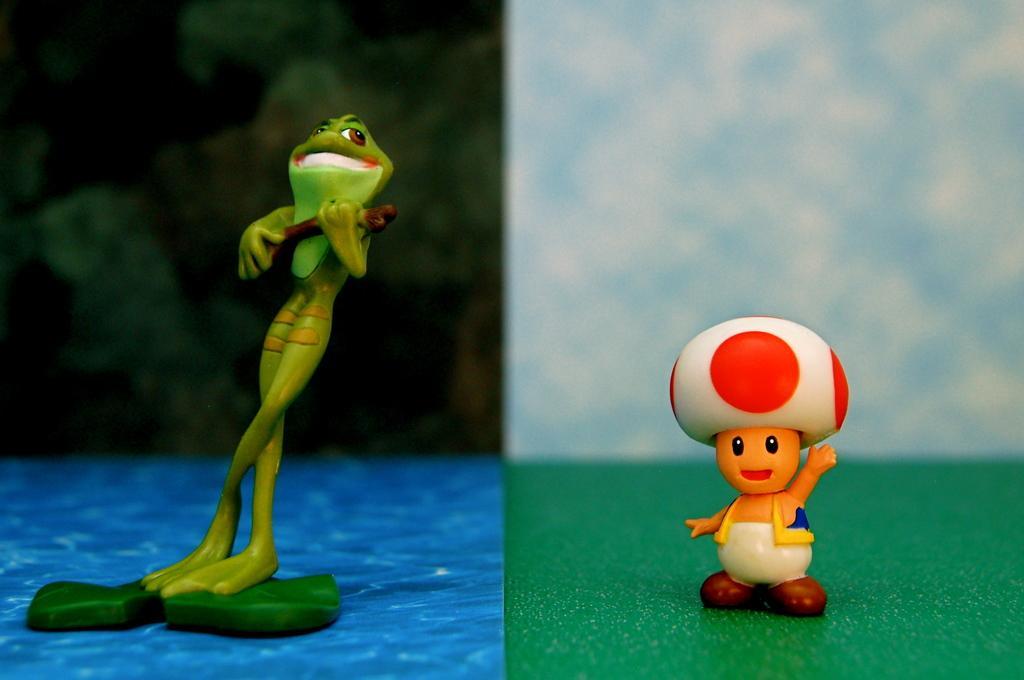How would you summarize this image in a sentence or two? In this image I can see a collage picture in which I can see a toy which is green in color which is in the shape of a frog and another toy which is in the shape of a person on the green colored surface. 